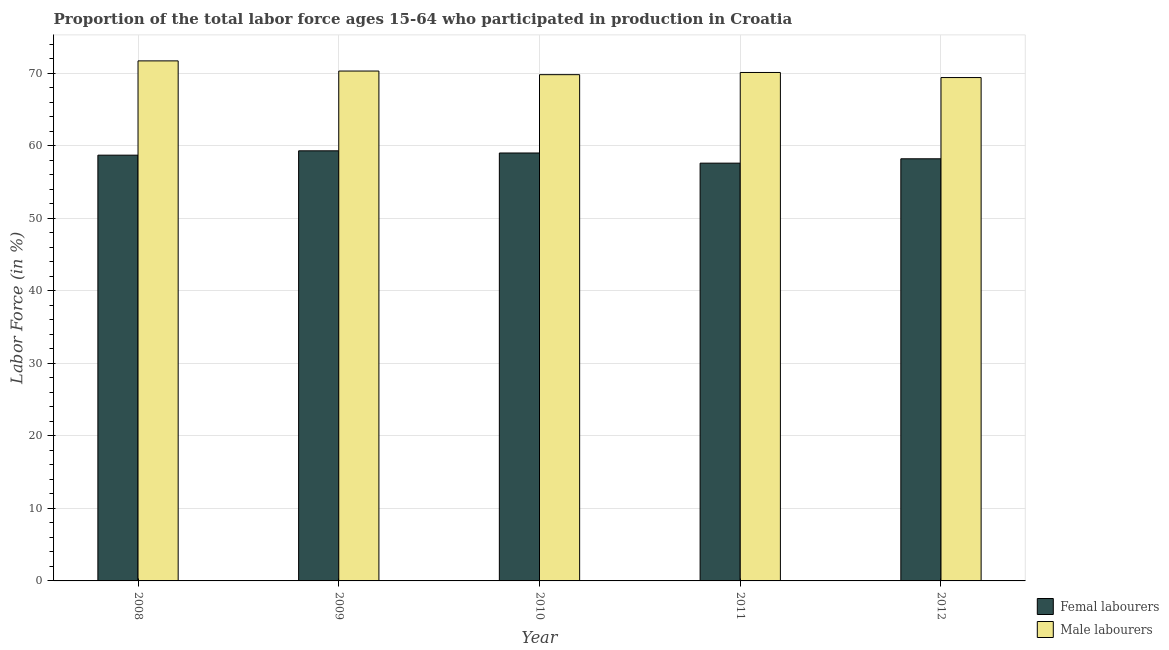How many groups of bars are there?
Provide a short and direct response. 5. Are the number of bars per tick equal to the number of legend labels?
Your answer should be very brief. Yes. How many bars are there on the 1st tick from the left?
Your response must be concise. 2. In how many cases, is the number of bars for a given year not equal to the number of legend labels?
Offer a terse response. 0. What is the percentage of female labor force in 2009?
Ensure brevity in your answer.  59.3. Across all years, what is the maximum percentage of female labor force?
Your answer should be very brief. 59.3. Across all years, what is the minimum percentage of female labor force?
Your answer should be compact. 57.6. In which year was the percentage of female labor force maximum?
Provide a succinct answer. 2009. In which year was the percentage of female labor force minimum?
Provide a short and direct response. 2011. What is the total percentage of male labour force in the graph?
Keep it short and to the point. 351.3. What is the difference between the percentage of female labor force in 2010 and that in 2012?
Ensure brevity in your answer.  0.8. What is the average percentage of male labour force per year?
Keep it short and to the point. 70.26. In the year 2008, what is the difference between the percentage of female labor force and percentage of male labour force?
Provide a short and direct response. 0. In how many years, is the percentage of female labor force greater than 44 %?
Offer a terse response. 5. What is the ratio of the percentage of female labor force in 2010 to that in 2012?
Provide a short and direct response. 1.01. Is the percentage of female labor force in 2010 less than that in 2011?
Provide a short and direct response. No. Is the difference between the percentage of female labor force in 2011 and 2012 greater than the difference between the percentage of male labour force in 2011 and 2012?
Keep it short and to the point. No. What is the difference between the highest and the second highest percentage of female labor force?
Offer a terse response. 0.3. What is the difference between the highest and the lowest percentage of male labour force?
Your answer should be very brief. 2.3. In how many years, is the percentage of male labour force greater than the average percentage of male labour force taken over all years?
Provide a short and direct response. 2. What does the 2nd bar from the left in 2008 represents?
Make the answer very short. Male labourers. What does the 1st bar from the right in 2010 represents?
Provide a succinct answer. Male labourers. What is the difference between two consecutive major ticks on the Y-axis?
Provide a short and direct response. 10. Does the graph contain grids?
Ensure brevity in your answer.  Yes. Where does the legend appear in the graph?
Ensure brevity in your answer.  Bottom right. What is the title of the graph?
Ensure brevity in your answer.  Proportion of the total labor force ages 15-64 who participated in production in Croatia. What is the label or title of the X-axis?
Your response must be concise. Year. What is the label or title of the Y-axis?
Your response must be concise. Labor Force (in %). What is the Labor Force (in %) of Femal labourers in 2008?
Offer a very short reply. 58.7. What is the Labor Force (in %) of Male labourers in 2008?
Provide a succinct answer. 71.7. What is the Labor Force (in %) in Femal labourers in 2009?
Your answer should be very brief. 59.3. What is the Labor Force (in %) in Male labourers in 2009?
Your answer should be compact. 70.3. What is the Labor Force (in %) in Male labourers in 2010?
Ensure brevity in your answer.  69.8. What is the Labor Force (in %) in Femal labourers in 2011?
Keep it short and to the point. 57.6. What is the Labor Force (in %) in Male labourers in 2011?
Provide a short and direct response. 70.1. What is the Labor Force (in %) in Femal labourers in 2012?
Give a very brief answer. 58.2. What is the Labor Force (in %) of Male labourers in 2012?
Provide a short and direct response. 69.4. Across all years, what is the maximum Labor Force (in %) of Femal labourers?
Give a very brief answer. 59.3. Across all years, what is the maximum Labor Force (in %) of Male labourers?
Offer a very short reply. 71.7. Across all years, what is the minimum Labor Force (in %) in Femal labourers?
Your response must be concise. 57.6. Across all years, what is the minimum Labor Force (in %) of Male labourers?
Offer a very short reply. 69.4. What is the total Labor Force (in %) of Femal labourers in the graph?
Provide a short and direct response. 292.8. What is the total Labor Force (in %) of Male labourers in the graph?
Your answer should be very brief. 351.3. What is the difference between the Labor Force (in %) in Femal labourers in 2008 and that in 2009?
Provide a succinct answer. -0.6. What is the difference between the Labor Force (in %) of Femal labourers in 2008 and that in 2010?
Offer a terse response. -0.3. What is the difference between the Labor Force (in %) of Male labourers in 2008 and that in 2010?
Your response must be concise. 1.9. What is the difference between the Labor Force (in %) of Male labourers in 2008 and that in 2011?
Your response must be concise. 1.6. What is the difference between the Labor Force (in %) of Femal labourers in 2008 and that in 2012?
Provide a succinct answer. 0.5. What is the difference between the Labor Force (in %) of Male labourers in 2009 and that in 2010?
Make the answer very short. 0.5. What is the difference between the Labor Force (in %) of Femal labourers in 2009 and that in 2011?
Provide a short and direct response. 1.7. What is the difference between the Labor Force (in %) of Male labourers in 2009 and that in 2012?
Offer a very short reply. 0.9. What is the difference between the Labor Force (in %) of Femal labourers in 2008 and the Labor Force (in %) of Male labourers in 2009?
Your response must be concise. -11.6. What is the difference between the Labor Force (in %) in Femal labourers in 2008 and the Labor Force (in %) in Male labourers in 2011?
Offer a very short reply. -11.4. What is the difference between the Labor Force (in %) in Femal labourers in 2008 and the Labor Force (in %) in Male labourers in 2012?
Offer a terse response. -10.7. What is the difference between the Labor Force (in %) of Femal labourers in 2009 and the Labor Force (in %) of Male labourers in 2010?
Offer a terse response. -10.5. What is the difference between the Labor Force (in %) of Femal labourers in 2009 and the Labor Force (in %) of Male labourers in 2011?
Your answer should be compact. -10.8. What is the difference between the Labor Force (in %) of Femal labourers in 2009 and the Labor Force (in %) of Male labourers in 2012?
Your answer should be compact. -10.1. What is the difference between the Labor Force (in %) of Femal labourers in 2010 and the Labor Force (in %) of Male labourers in 2012?
Ensure brevity in your answer.  -10.4. What is the average Labor Force (in %) of Femal labourers per year?
Your response must be concise. 58.56. What is the average Labor Force (in %) of Male labourers per year?
Make the answer very short. 70.26. In the year 2009, what is the difference between the Labor Force (in %) of Femal labourers and Labor Force (in %) of Male labourers?
Make the answer very short. -11. In the year 2010, what is the difference between the Labor Force (in %) in Femal labourers and Labor Force (in %) in Male labourers?
Ensure brevity in your answer.  -10.8. What is the ratio of the Labor Force (in %) of Male labourers in 2008 to that in 2009?
Ensure brevity in your answer.  1.02. What is the ratio of the Labor Force (in %) in Femal labourers in 2008 to that in 2010?
Provide a short and direct response. 0.99. What is the ratio of the Labor Force (in %) of Male labourers in 2008 to that in 2010?
Give a very brief answer. 1.03. What is the ratio of the Labor Force (in %) in Femal labourers in 2008 to that in 2011?
Give a very brief answer. 1.02. What is the ratio of the Labor Force (in %) of Male labourers in 2008 to that in 2011?
Your response must be concise. 1.02. What is the ratio of the Labor Force (in %) in Femal labourers in 2008 to that in 2012?
Ensure brevity in your answer.  1.01. What is the ratio of the Labor Force (in %) in Male labourers in 2008 to that in 2012?
Offer a very short reply. 1.03. What is the ratio of the Labor Force (in %) of Femal labourers in 2009 to that in 2010?
Keep it short and to the point. 1.01. What is the ratio of the Labor Force (in %) in Male labourers in 2009 to that in 2010?
Your response must be concise. 1.01. What is the ratio of the Labor Force (in %) of Femal labourers in 2009 to that in 2011?
Keep it short and to the point. 1.03. What is the ratio of the Labor Force (in %) in Femal labourers in 2009 to that in 2012?
Give a very brief answer. 1.02. What is the ratio of the Labor Force (in %) in Male labourers in 2009 to that in 2012?
Your answer should be compact. 1.01. What is the ratio of the Labor Force (in %) of Femal labourers in 2010 to that in 2011?
Offer a terse response. 1.02. What is the ratio of the Labor Force (in %) in Male labourers in 2010 to that in 2011?
Keep it short and to the point. 1. What is the ratio of the Labor Force (in %) in Femal labourers in 2010 to that in 2012?
Your response must be concise. 1.01. What is the difference between the highest and the lowest Labor Force (in %) of Male labourers?
Offer a very short reply. 2.3. 